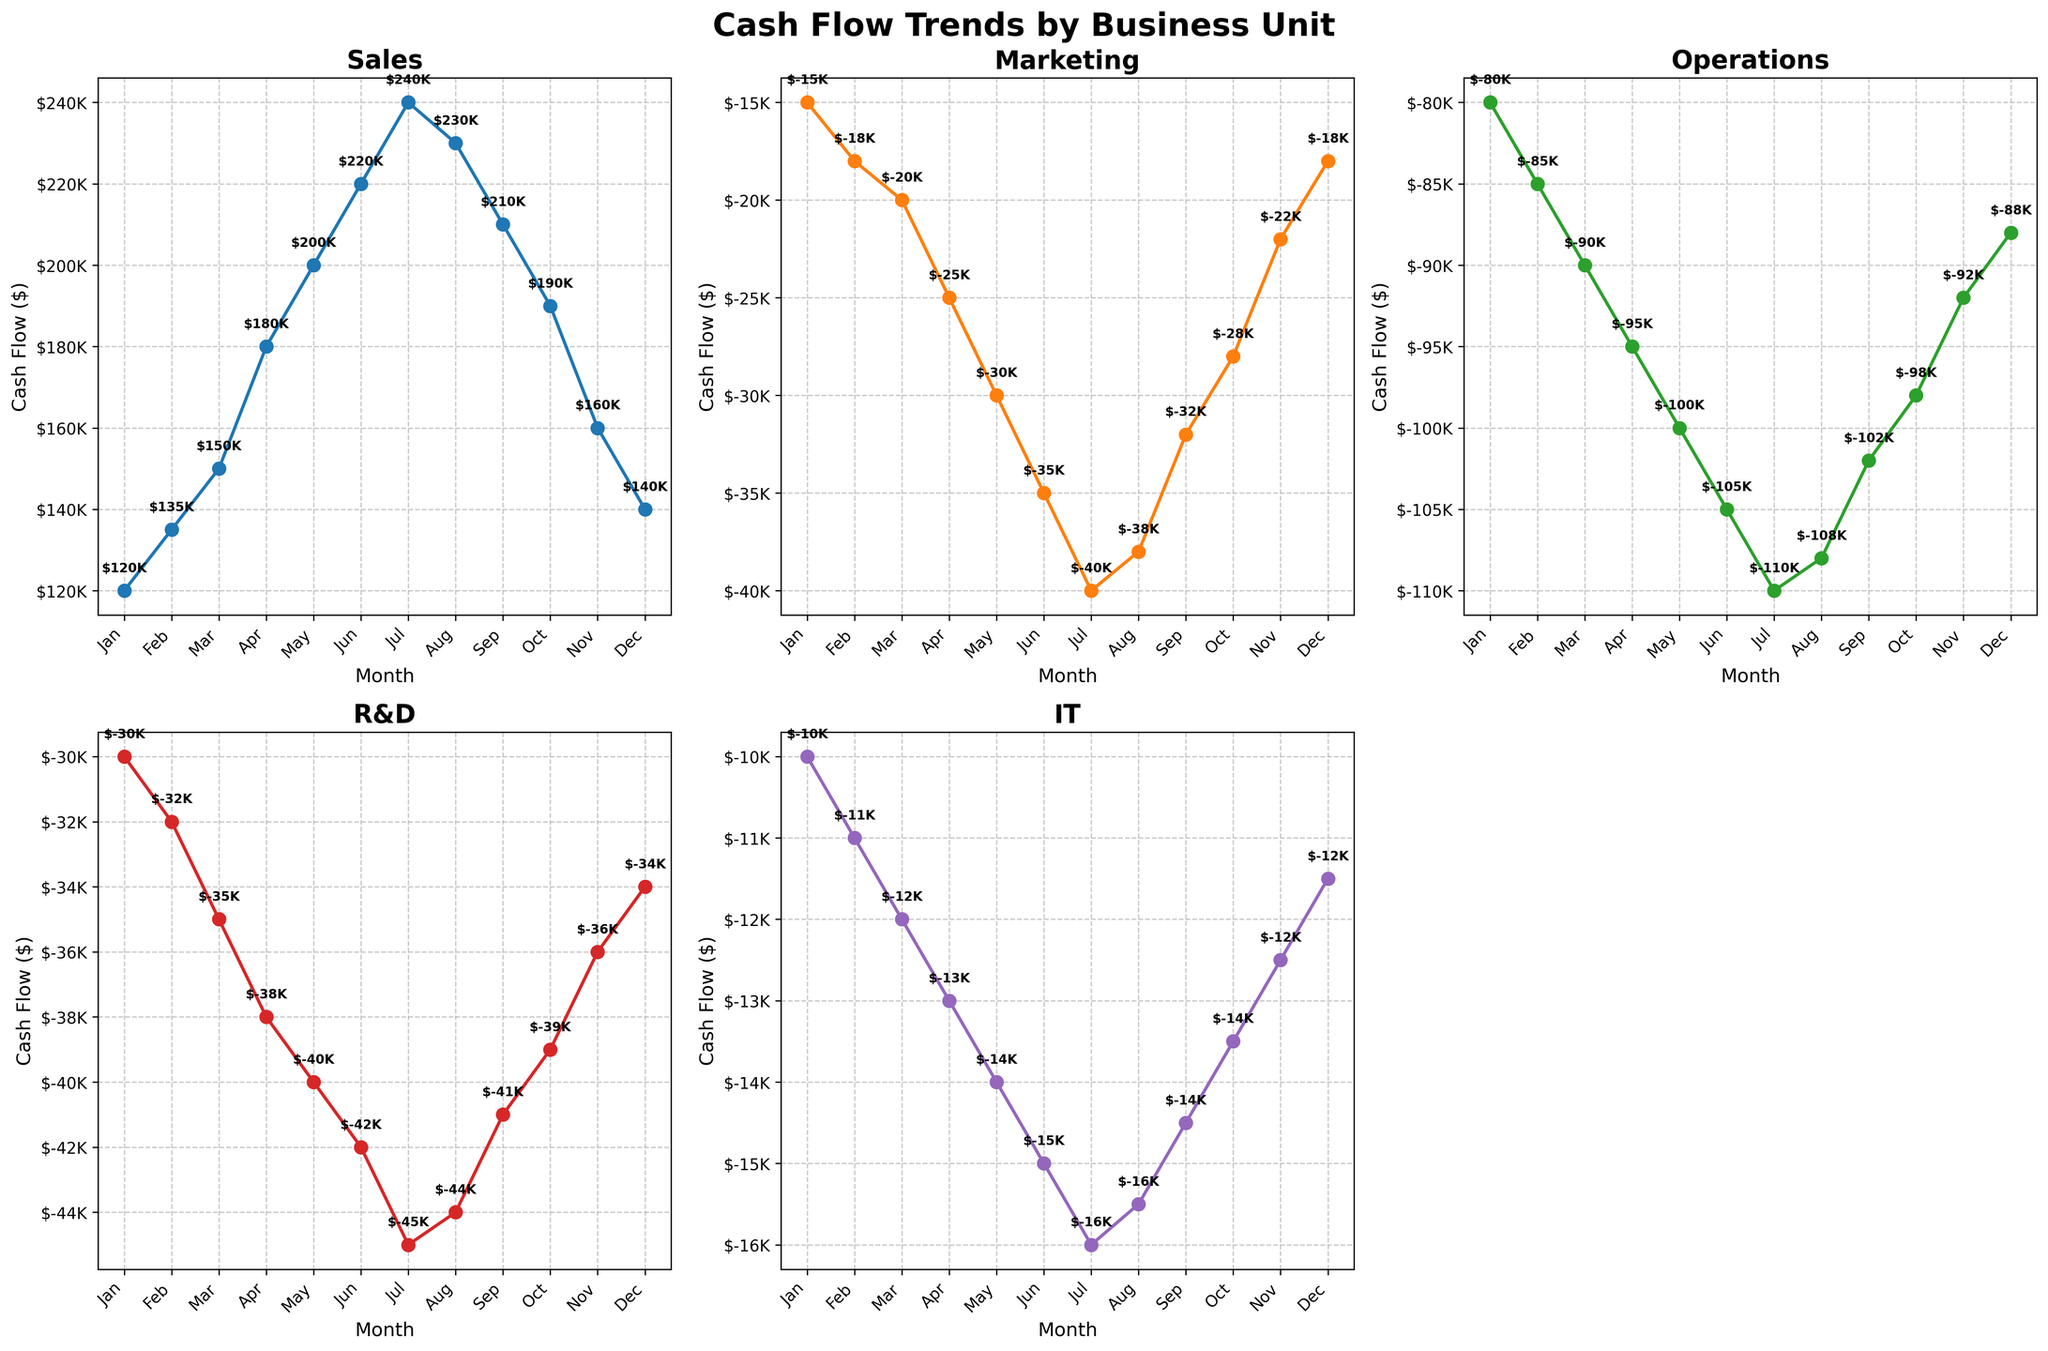What is the title of the entire figure? The title is clearly displayed on top of the figure in bold font, reading "Cash Flow Trends by Business Unit".
Answer: Cash Flow Trends by Business Unit Which month has the highest cash flow for Sales? By examining the Sales subplot, it is evident that the cash flow peaks in July with a value of $240K.
Answer: July How does the cash flow in Marketing compare between January and December? In January, the cash flow for Marketing is -$15K, and in December, it is -$18K, indicating a decline of $3K over the year.
Answer: Declined by $3K What is the average cash flow for R&D across the entire year? Adding up the monthly cash flows for R&D: -30K, -32K, -35K, -38K, -40K, -42K, -45K, -44K, -41K, -39K, -36K, -34K, the total is -466K. Dividing this by 12 months yields an average cash flow of -$38.83K.
Answer: -$38.83K In which month does IT have the lowest cash flow, and what is the value? Observing the IT subplot, the lowest cash flow is noted in July with a value of -$16K.
Answer: July, -$16K Which business unit shows a positive cash flow trend throughout the year? Upon examining all subplots, Sales consistently shows an increasing positive cash flow trend across all months.
Answer: Sales Which month shows the greatest reduction in cash flow for Operations? Comparing all months in the Operations subplot, the largest reduction occurs from June to July, dropping from -$105K to -$110K, a decrease of $5K.
Answer: July Which two business units exhibit seasonal fluctuations in their cash flow trends? The subplots for Marketing and IT exhibit patterns that rise and fall across different months, indicating seasonal fluctuations.
Answer: Marketing, IT How does the cash flow for R&D in February compare to June? By viewing the R&D subplot, the cash flow in February is -$32K and in June it is -$42K, indicating a reduction of $10K.
Answer: Reduced by $10K What is the overall trend in cash flow for the Operations unit across the year? The Operations subplot shows a consistent decline in cash flow from -$80K in January to -$110K in July, before slightly recovering towards December at -$88K.
Answer: Declining trend overall 